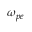Convert formula to latex. <formula><loc_0><loc_0><loc_500><loc_500>\omega _ { p e }</formula> 